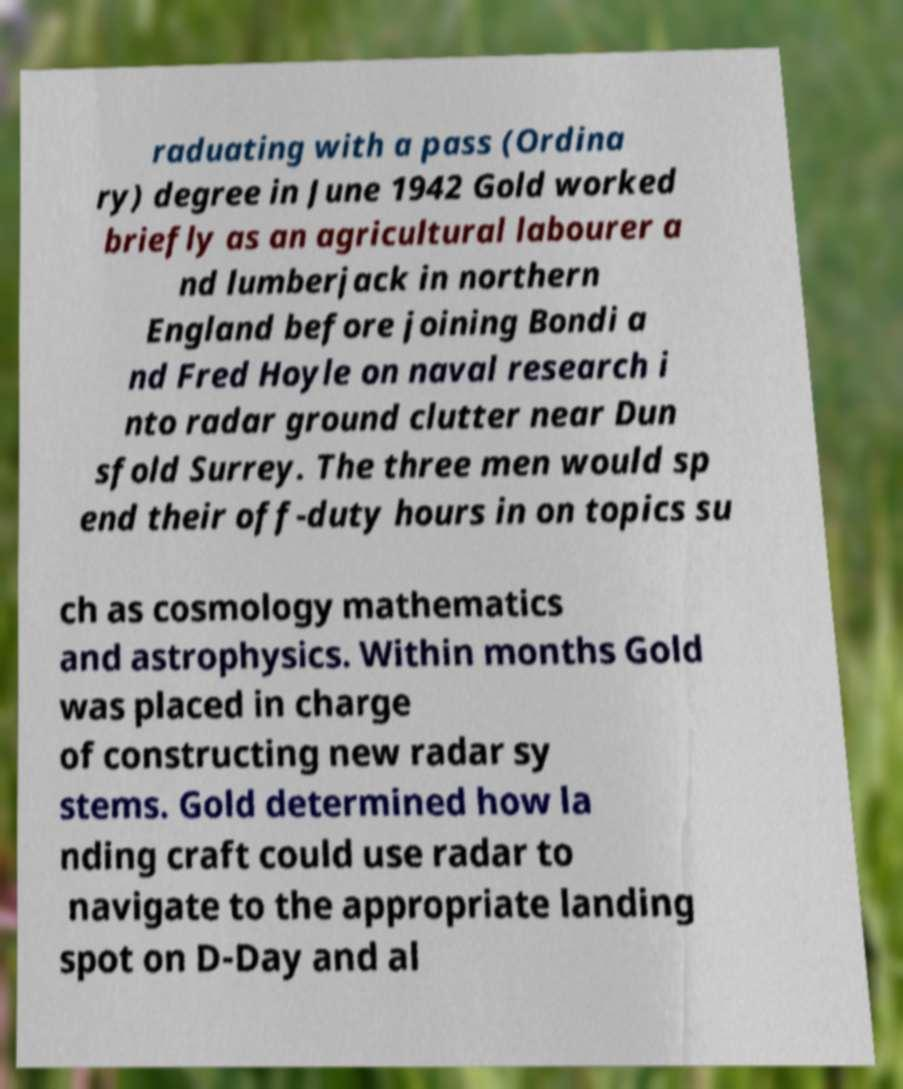Can you read and provide the text displayed in the image?This photo seems to have some interesting text. Can you extract and type it out for me? raduating with a pass (Ordina ry) degree in June 1942 Gold worked briefly as an agricultural labourer a nd lumberjack in northern England before joining Bondi a nd Fred Hoyle on naval research i nto radar ground clutter near Dun sfold Surrey. The three men would sp end their off-duty hours in on topics su ch as cosmology mathematics and astrophysics. Within months Gold was placed in charge of constructing new radar sy stems. Gold determined how la nding craft could use radar to navigate to the appropriate landing spot on D-Day and al 